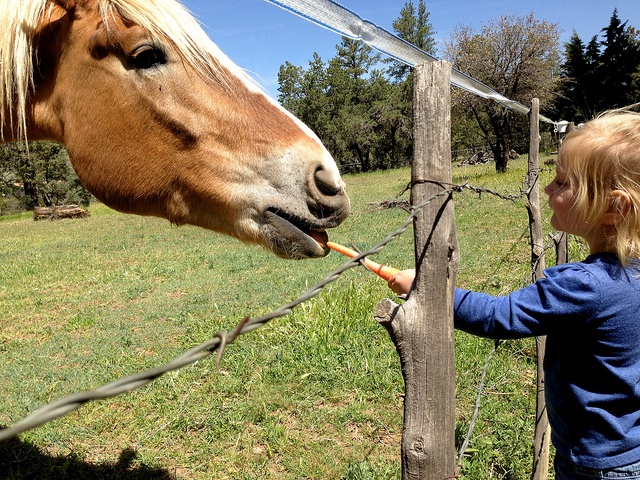Describe the objects in this image and their specific colors. I can see horse in lightyellow, brown, black, tan, and maroon tones, people in lightyellow, black, gray, maroon, and navy tones, and carrot in lightyellow, khaki, orange, and red tones in this image. 